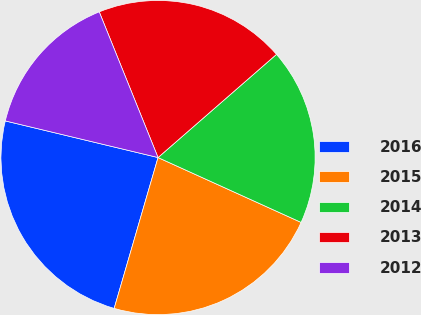Convert chart to OTSL. <chart><loc_0><loc_0><loc_500><loc_500><pie_chart><fcel>2016<fcel>2015<fcel>2014<fcel>2013<fcel>2012<nl><fcel>24.24%<fcel>22.73%<fcel>18.18%<fcel>19.7%<fcel>15.15%<nl></chart> 